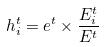<formula> <loc_0><loc_0><loc_500><loc_500>h _ { i } ^ { t } = e ^ { t } \times \frac { E _ { i } ^ { t } } { E ^ { t } }</formula> 